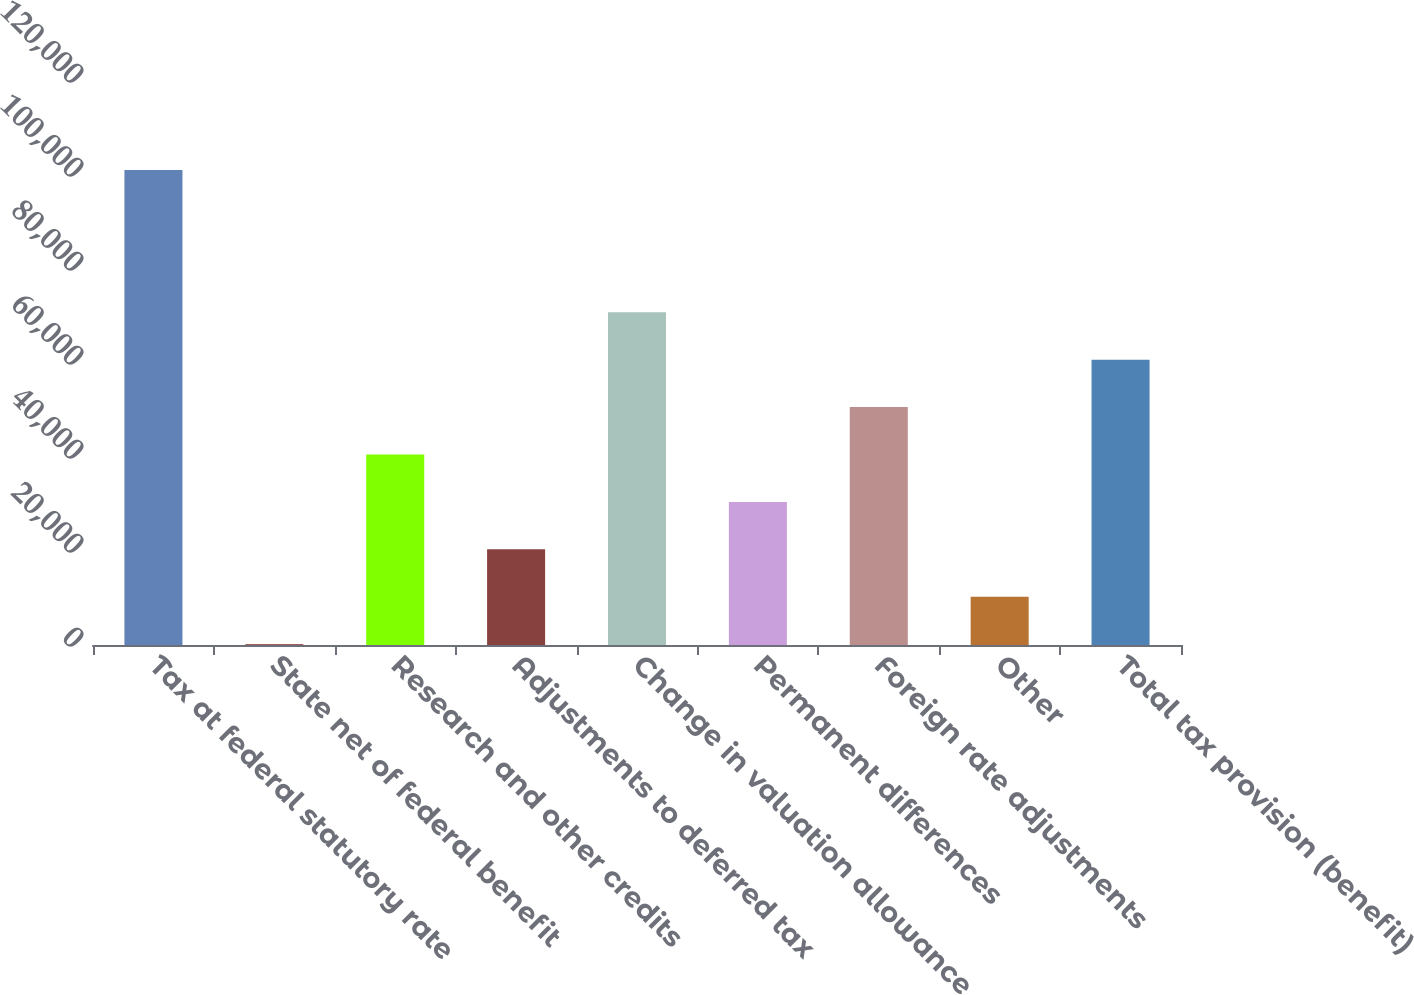Convert chart to OTSL. <chart><loc_0><loc_0><loc_500><loc_500><bar_chart><fcel>Tax at federal statutory rate<fcel>State net of federal benefit<fcel>Research and other credits<fcel>Adjustments to deferred tax<fcel>Change in valuation allowance<fcel>Permanent differences<fcel>Foreign rate adjustments<fcel>Other<fcel>Total tax provision (benefit)<nl><fcel>101075<fcel>174<fcel>40534.4<fcel>20354.2<fcel>70804.7<fcel>30444.3<fcel>50624.5<fcel>10264.1<fcel>60714.6<nl></chart> 